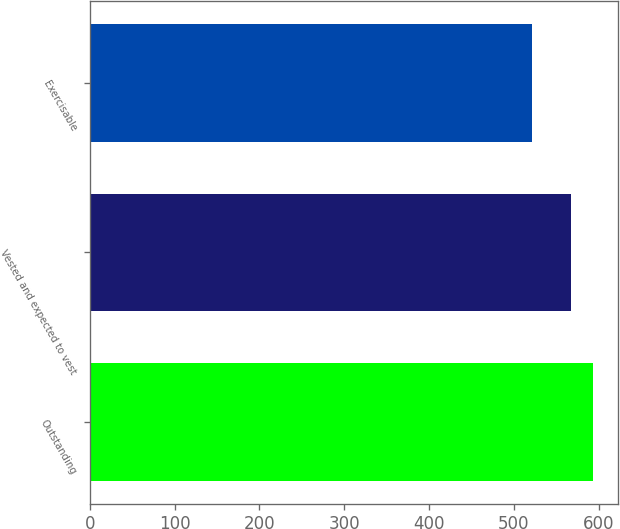Convert chart. <chart><loc_0><loc_0><loc_500><loc_500><bar_chart><fcel>Outstanding<fcel>Vested and expected to vest<fcel>Exercisable<nl><fcel>593<fcel>568<fcel>521<nl></chart> 